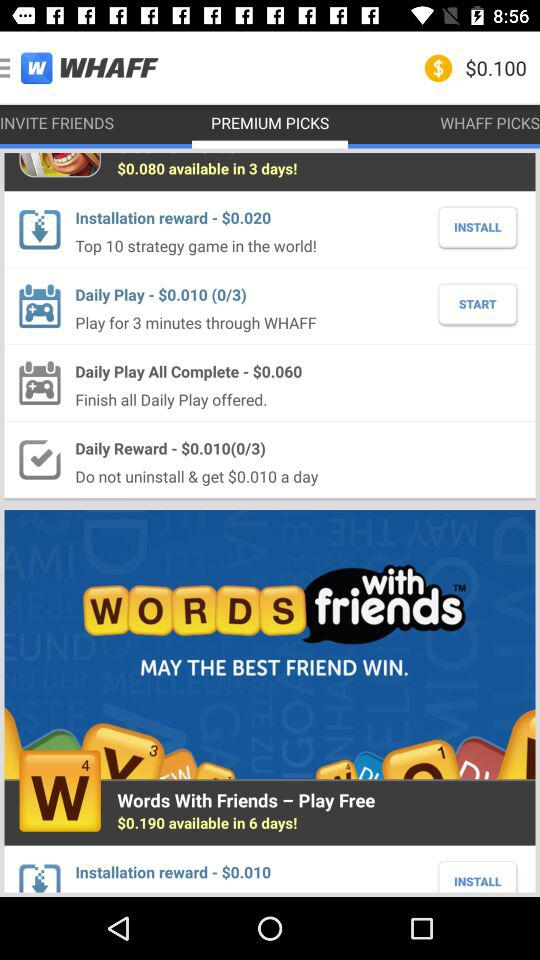What is the amount of daily reward? The amount of daily reward is $0.010. 